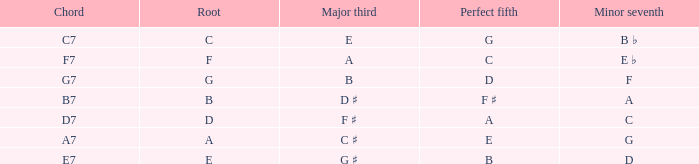What is the Chord with a Major that is third of e? C7. 